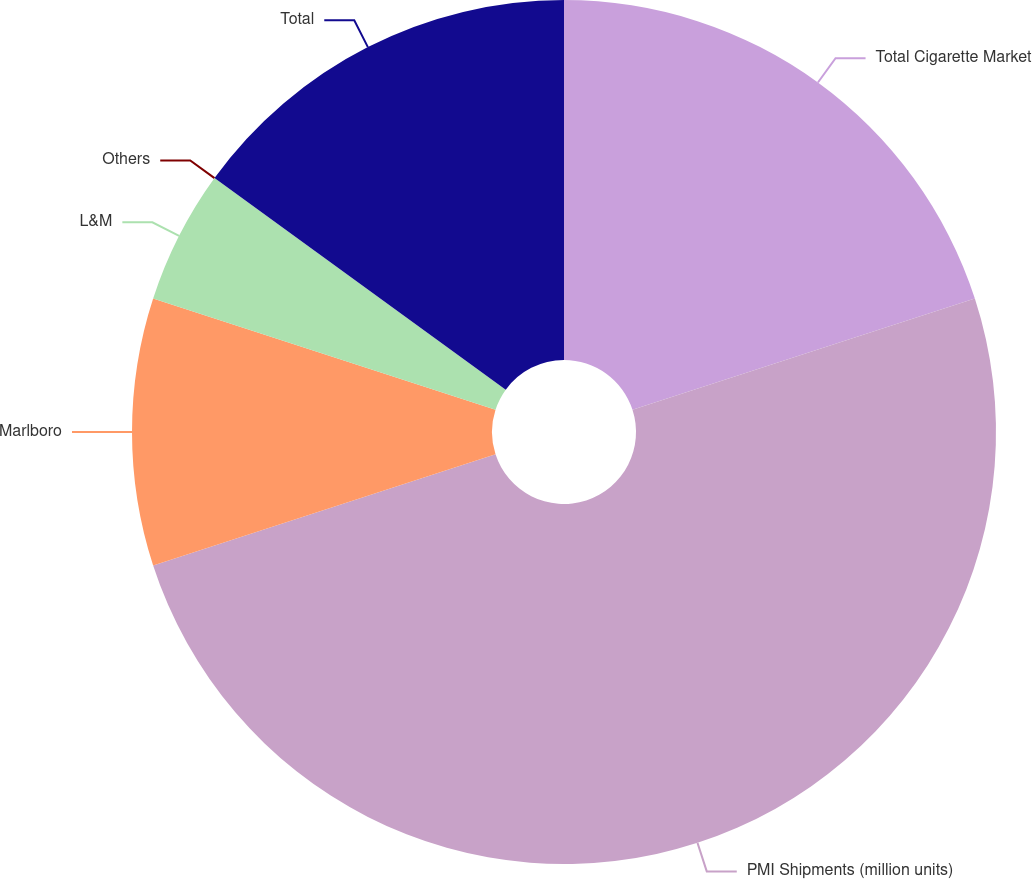Convert chart. <chart><loc_0><loc_0><loc_500><loc_500><pie_chart><fcel>Total Cigarette Market<fcel>PMI Shipments (million units)<fcel>Marlboro<fcel>L&M<fcel>Others<fcel>Total<nl><fcel>20.0%<fcel>50.0%<fcel>10.0%<fcel>5.0%<fcel>0.0%<fcel>15.0%<nl></chart> 